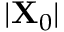Convert formula to latex. <formula><loc_0><loc_0><loc_500><loc_500>| X _ { 0 } |</formula> 